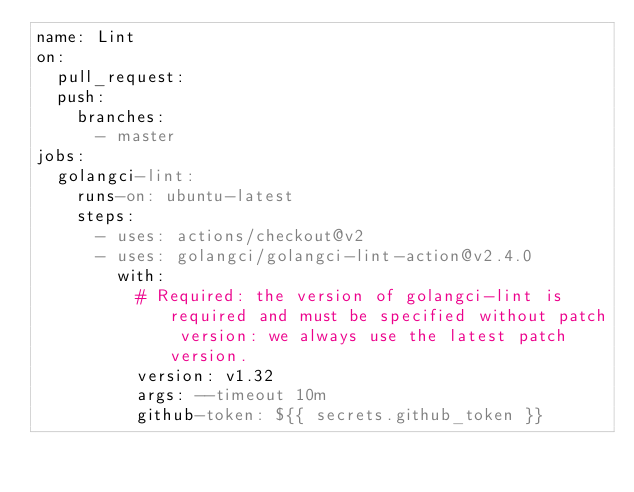Convert code to text. <code><loc_0><loc_0><loc_500><loc_500><_YAML_>name: Lint
on:
  pull_request:
  push:
    branches:
      - master
jobs:
  golangci-lint:
    runs-on: ubuntu-latest
    steps:
      - uses: actions/checkout@v2
      - uses: golangci/golangci-lint-action@v2.4.0
        with:
          # Required: the version of golangci-lint is required and must be specified without patch version: we always use the latest patch version.
          version: v1.32
          args: --timeout 10m
          github-token: ${{ secrets.github_token }}
</code> 